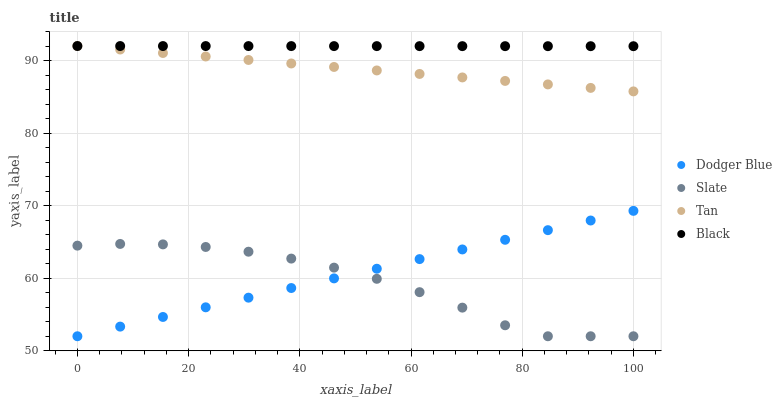Does Slate have the minimum area under the curve?
Answer yes or no. Yes. Does Black have the maximum area under the curve?
Answer yes or no. Yes. Does Dodger Blue have the minimum area under the curve?
Answer yes or no. No. Does Dodger Blue have the maximum area under the curve?
Answer yes or no. No. Is Black the smoothest?
Answer yes or no. Yes. Is Slate the roughest?
Answer yes or no. Yes. Is Dodger Blue the smoothest?
Answer yes or no. No. Is Dodger Blue the roughest?
Answer yes or no. No. Does Slate have the lowest value?
Answer yes or no. Yes. Does Tan have the lowest value?
Answer yes or no. No. Does Tan have the highest value?
Answer yes or no. Yes. Does Dodger Blue have the highest value?
Answer yes or no. No. Is Slate less than Tan?
Answer yes or no. Yes. Is Tan greater than Dodger Blue?
Answer yes or no. Yes. Does Tan intersect Black?
Answer yes or no. Yes. Is Tan less than Black?
Answer yes or no. No. Is Tan greater than Black?
Answer yes or no. No. Does Slate intersect Tan?
Answer yes or no. No. 